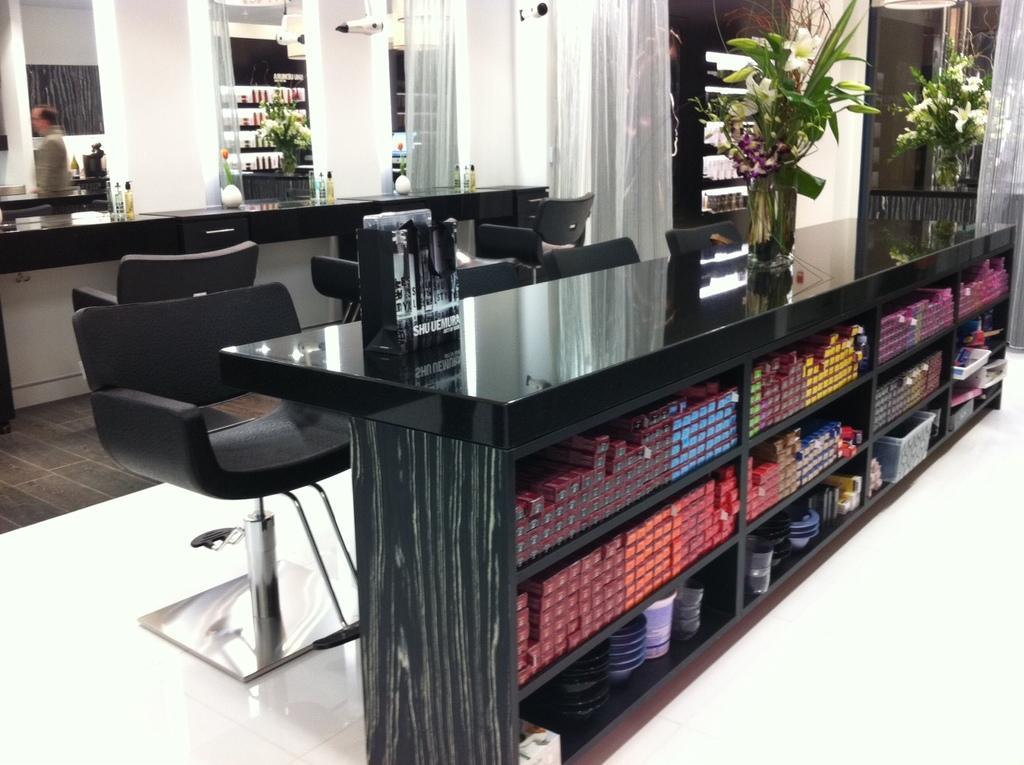In one or two sentences, can you explain what this image depicts? In the center of the image there are tables and we can see flower bouquets, bottles and sprays placed on the tables. There are chairs and we can see things placed in the shelf. In the background there is a mirror and curtains. 